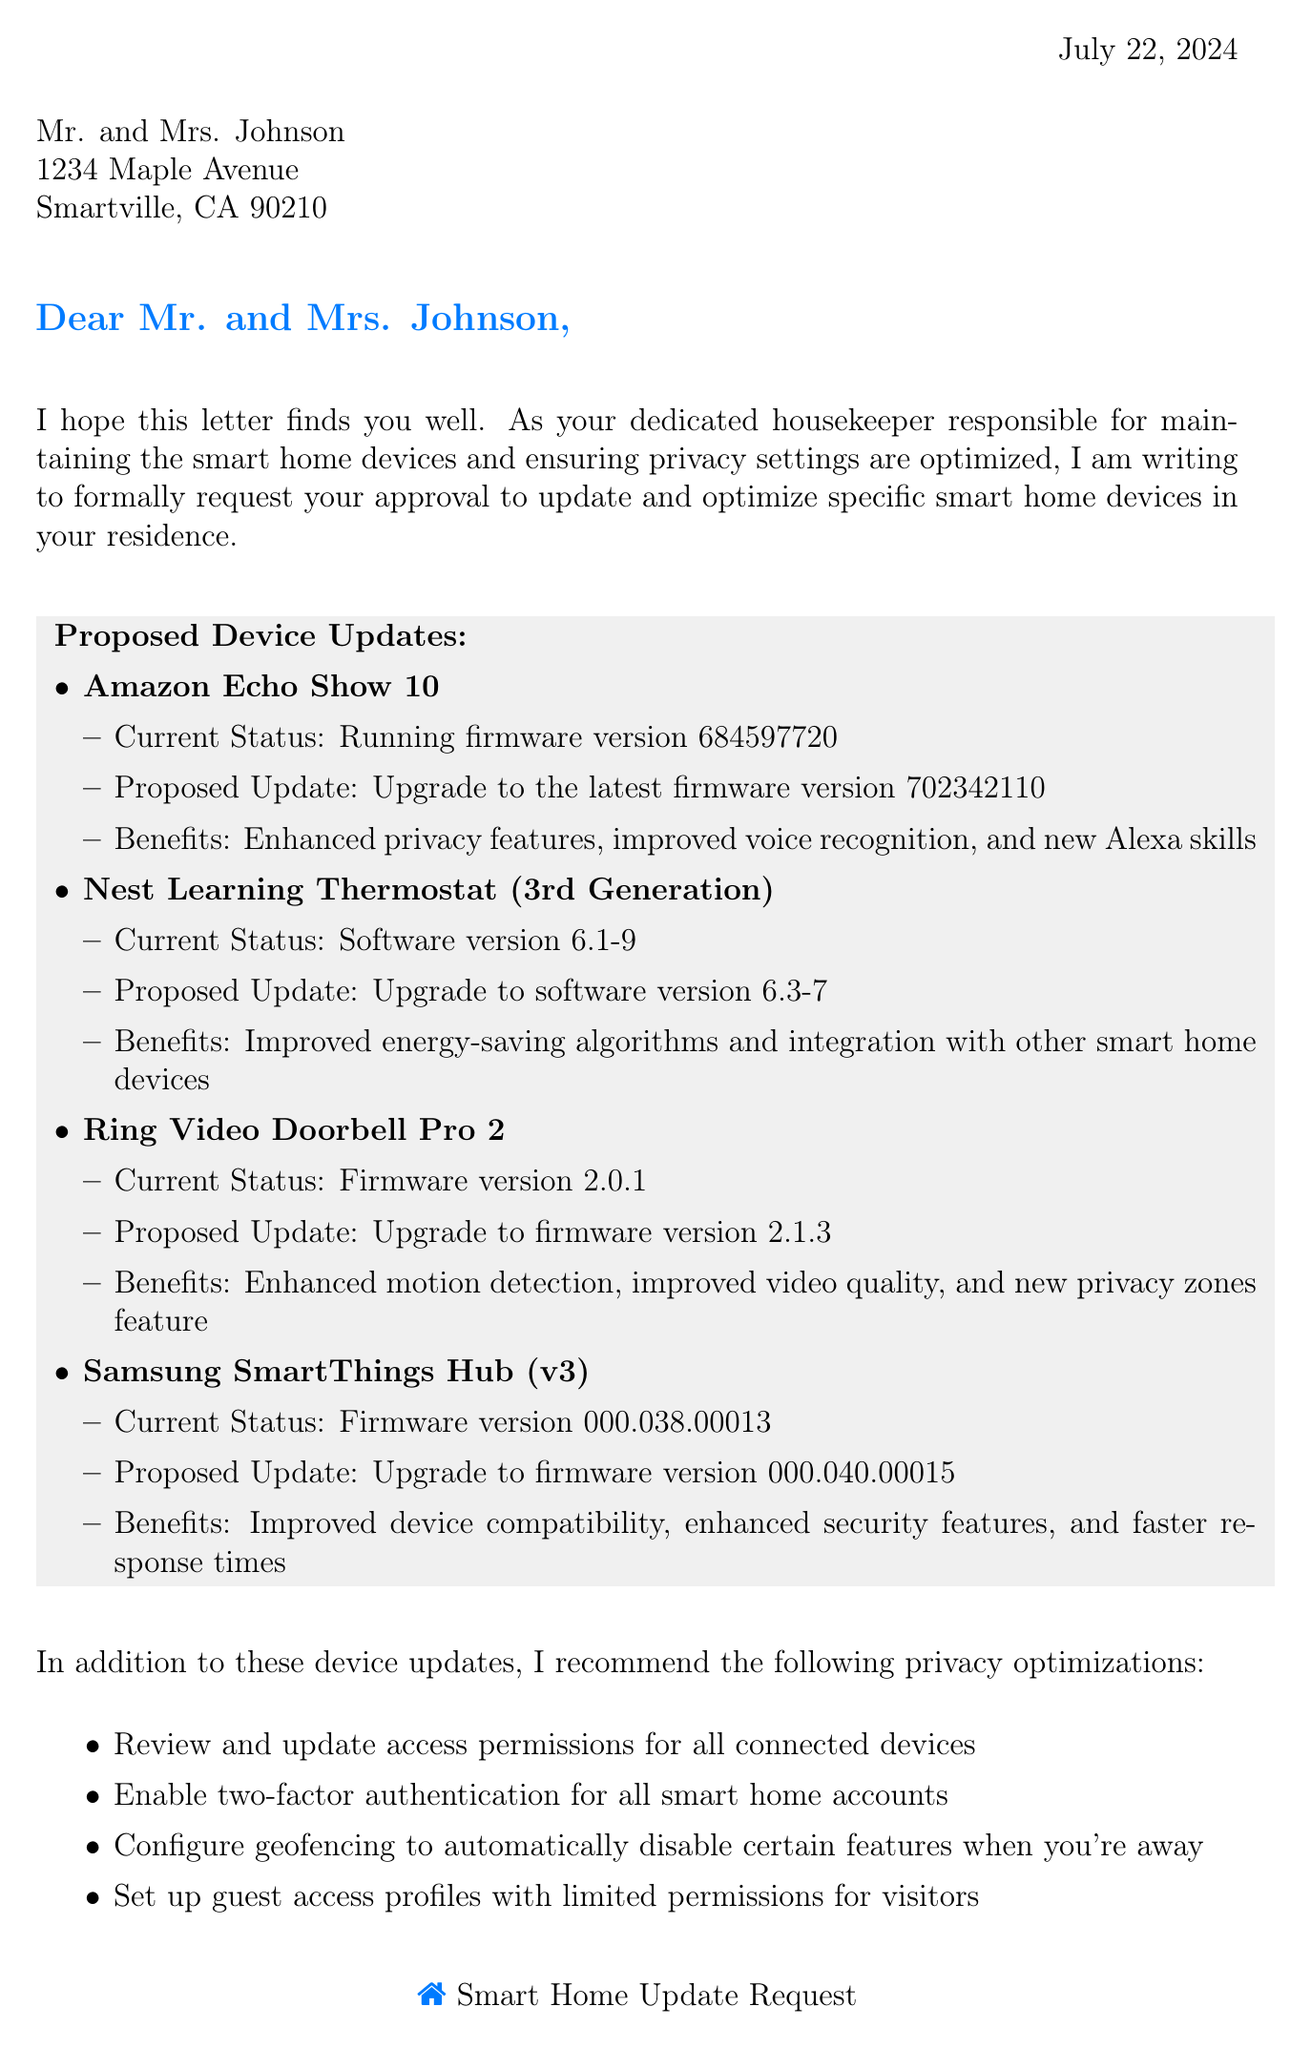What is the date of the letter? The date is found in the top right corner of the document, indicating when the letter was written.
Answer: Today's date Who is the housekeeper? The letter mentions the responsible housekeeper at the end, identifying who wrote the letter.
Answer: Emily Parker What is the proposed update for the Amazon Echo Show 10? The letter specifies the firmware version to upgrade to for the Amazon Echo Show 10 under proposed updates.
Answer: Upgrade to the latest firmware version 702342110 What is one benefit of updating the Ring Video Doorbell Pro 2? The letter lists benefits for each device update, including improvements for the Ring Video Doorbell.
Answer: Enhanced motion detection How many privacy optimization suggestions are provided? The number of privacy suggestions is stated within the section discussing privacy optimizations in the document.
Answer: Four What current firmware version is the Samsung SmartThings Hub running? The letter provides the current firmware details for each device, including the Samsung SmartThings Hub.
Answer: Firmware version 000.038.00013 What is the name of the homeowners? The name of the homeowners is mentioned in the address section of the letter.
Answer: Mr. and Mrs. Johnson Is geofencing recommended in the privacy optimizations? The document lists recommendations for privacy optimizations, including the concept of geofencing.
Answer: Yes 